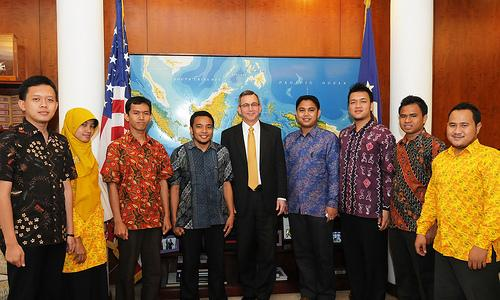What unique accessory can be seen on one of the people in the image? A black-colored wristwatch can be seen on one of the people. In a few words, describe the primary sentiment this image conveys. Unity, diversity, and collaboration. How many people are in the image, and how many of them are Asian? There are nine people in the image, with eight of them being Asian. Identify the main event displayed in this image. A group of people standing together in front of a wall with flags and a map, wearing various colored clothing. Describe the wall behind the people. The wall behind the people is shiny, smooth, and brown with a map and flags. What type of pattern is on the male's yellow shirt? There is an orange pattern on the male's yellow shirt. What is the primary objective of this image's analysis? To identify and understand the relationships between the objects, patterns, colors, and people in the image. What color are the pants of the man with the yellow tie? The man with the yellow tie is wearing black pants. Describe the woman wearing a yellow veil. The woman wearing the yellow veil is in a hijab, and she has a black wristwatch on. What is the color of the shirt worn by the man in the middle of the Asians? The man in the middle of the Asians is wearing a purplish shirt. Identify the dominant color and pattern of the male shirt with an orange design. Yellow with a yellow pattern Which object is hoisted up in the air among the people? An American flag Select the correct statement about the man wearing a black suit: a) the man is bald, b) the man has a beard, c) the man is in the background, d) the man is in the foreground d) the man is in the foreground What color are the pants of the man wearing a purplish shirt? Black Based on the people and objects in the scene, hypothesize the purpose of the gathering. A multicultural event or a conference on international affairs How would you describe the outfits worn by the people in the foreground? A variety of colorful and patterned clothing, including shirts, pants, ties, and a hijab Distinguish the objects that the people are standing in front of. Flags, a map, and a brown wall Narrate a short description of the interaction between the people in the picture. A diverse group of people in colorful outfits are gathered together, engaging in conversation or posing for a photo in front of flags and a map. Explain the activity taking place based on the position of the individuals in the image. A group of people posing for a photo or engaging in a discussion In an assertive sentence, summarize the main event or activity of the group of people. The group of people is gathered together in front of a map and flags, showcasing their varied cultural attires. Choose the correct description for the woman wearing a yellow veil from the options provided: a) woman in yellow hijab, b) person in a yellow hat, c) woman in a blue shirt, d) woman in a black dress a) woman in yellow hijab List the colors attributed to the ties featured in the image. Yellow and beige Describe the prominent feature of the wall that appears behind the people. Shiny and smooth brown wall What is the setting for the group of people, as described by the presence of specific objects? Standing in front of flags, a map, and a brown wall Analyze the position of the white man in the group of asians. White man standing in the middle of the asians Based on the event and the different attire of people, speculate the purpose of the gathering. A cultural event or a multi-ethnic gathering Capture the essence of the scene in a coherent and vivid short sentence. A diverse group of people stand together in front of flags and a map, wearing various colorful outfits. Identify the type of wrist accessory worn by an individual in the image. A black colored wrist watch How many asians are there in the group, and is there a white man present? Eight asians and one white man 